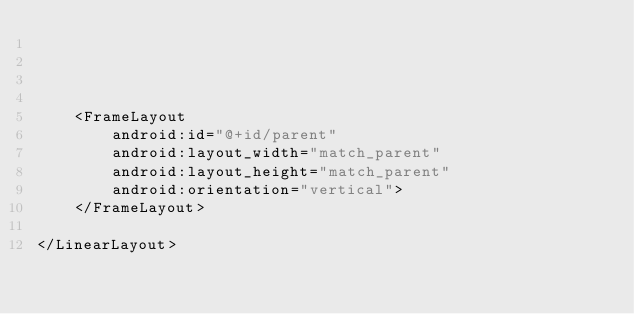Convert code to text. <code><loc_0><loc_0><loc_500><loc_500><_XML_>



    <FrameLayout
        android:id="@+id/parent"
        android:layout_width="match_parent"
        android:layout_height="match_parent"
        android:orientation="vertical">
    </FrameLayout>

</LinearLayout>
</code> 